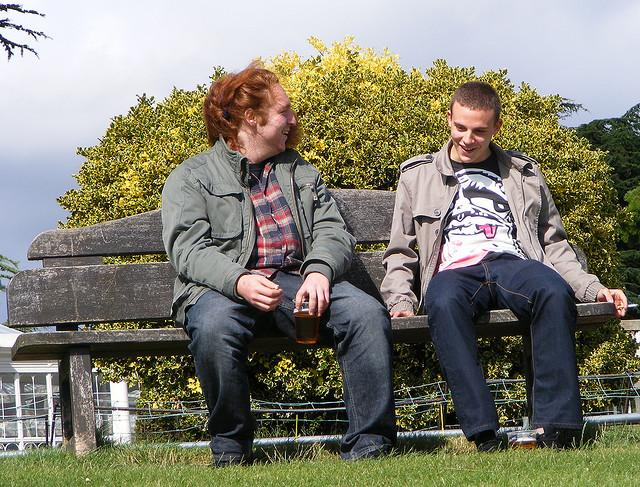What are the men sitting on?

Choices:
A) bench
B) grass
C) boulder
D) log bench 